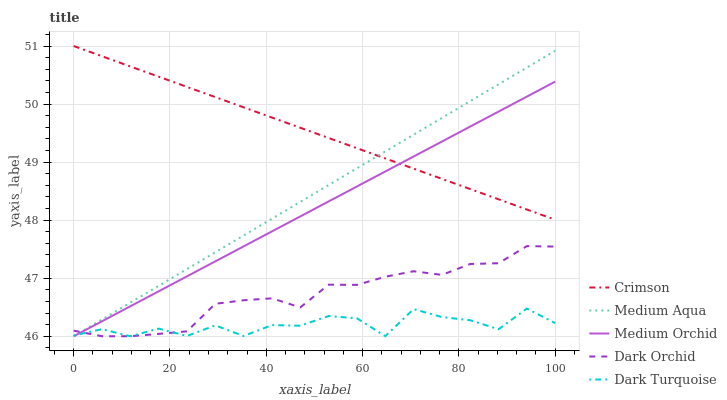Does Dark Turquoise have the minimum area under the curve?
Answer yes or no. Yes. Does Crimson have the maximum area under the curve?
Answer yes or no. Yes. Does Medium Orchid have the minimum area under the curve?
Answer yes or no. No. Does Medium Orchid have the maximum area under the curve?
Answer yes or no. No. Is Medium Orchid the smoothest?
Answer yes or no. Yes. Is Dark Turquoise the roughest?
Answer yes or no. Yes. Is Dark Turquoise the smoothest?
Answer yes or no. No. Is Medium Orchid the roughest?
Answer yes or no. No. Does Dark Turquoise have the lowest value?
Answer yes or no. Yes. Does Crimson have the highest value?
Answer yes or no. Yes. Does Medium Orchid have the highest value?
Answer yes or no. No. Is Dark Orchid less than Crimson?
Answer yes or no. Yes. Is Crimson greater than Dark Turquoise?
Answer yes or no. Yes. Does Dark Orchid intersect Dark Turquoise?
Answer yes or no. Yes. Is Dark Orchid less than Dark Turquoise?
Answer yes or no. No. Is Dark Orchid greater than Dark Turquoise?
Answer yes or no. No. Does Dark Orchid intersect Crimson?
Answer yes or no. No. 